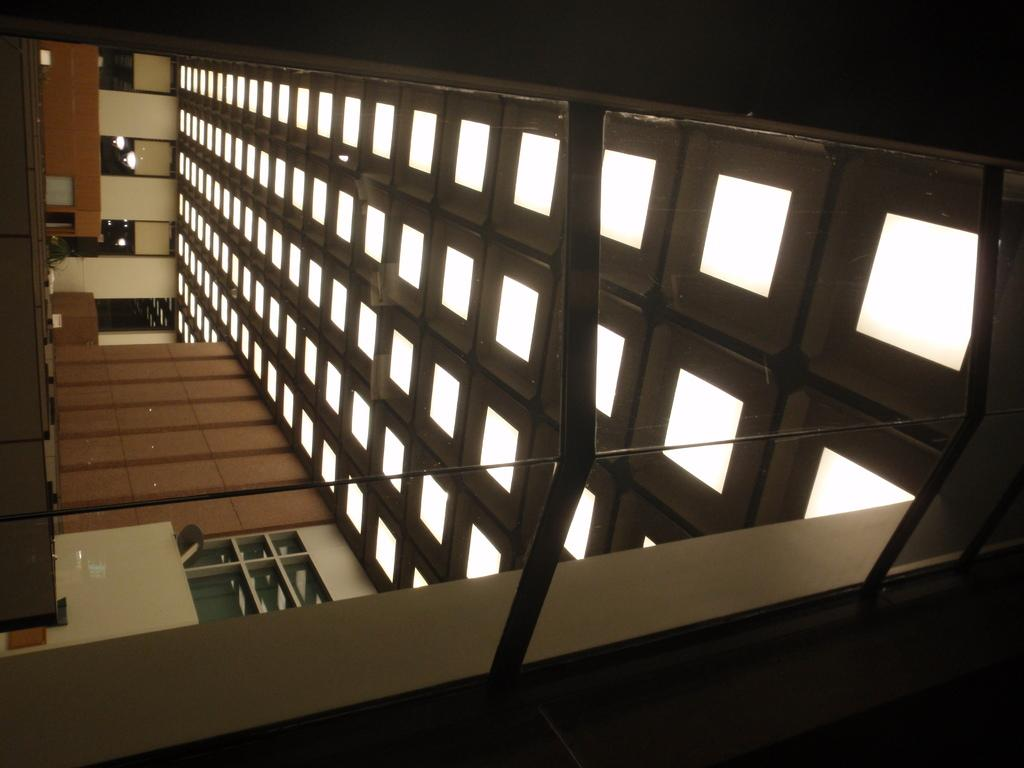What type of location is shown in the image? The image depicts the interior of a building. What architectural feature can be seen in the building? There are windows visible in the building. What is providing illumination in the building? There are lights in the ceiling of the building. What type of fiction can be seen on the seashore in the image? There is no seashore or fiction present in the image; it depicts the interior of a building. 